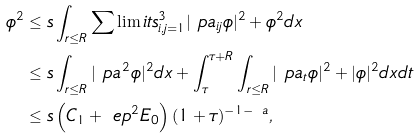Convert formula to latex. <formula><loc_0><loc_0><loc_500><loc_500>\phi ^ { 2 } & \leq s \int _ { r \leq R } \sum \lim i t s _ { i , j = 1 } ^ { 3 } | \ p a _ { i j } \phi | ^ { 2 } + \phi ^ { 2 } d x \\ & \leq s \int _ { r \leq R } | \ p a ^ { 2 } \phi | ^ { 2 } d x + \int _ { \tau } ^ { \tau + R } \int _ { r \leq R } | \ p a _ { t } \phi | ^ { 2 } + | \phi | ^ { 2 } d x d t \\ & \leq s \left ( C _ { 1 } + \ e p ^ { 2 } E _ { 0 } \right ) ( 1 + \tau ) ^ { - 1 - \ a } ,</formula> 